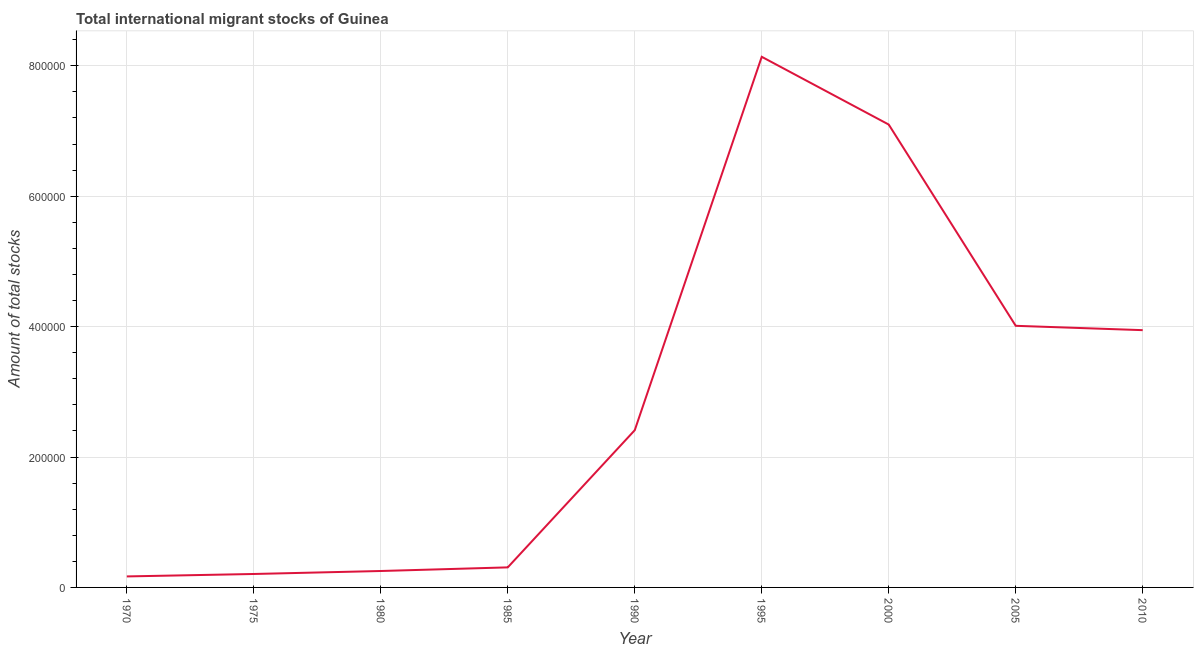What is the total number of international migrant stock in 1970?
Provide a succinct answer. 1.69e+04. Across all years, what is the maximum total number of international migrant stock?
Your response must be concise. 8.14e+05. Across all years, what is the minimum total number of international migrant stock?
Give a very brief answer. 1.69e+04. In which year was the total number of international migrant stock minimum?
Your response must be concise. 1970. What is the sum of the total number of international migrant stock?
Your answer should be very brief. 2.65e+06. What is the difference between the total number of international migrant stock in 1990 and 2005?
Your response must be concise. -1.60e+05. What is the average total number of international migrant stock per year?
Offer a very short reply. 2.95e+05. What is the median total number of international migrant stock?
Provide a short and direct response. 2.41e+05. In how many years, is the total number of international migrant stock greater than 240000 ?
Keep it short and to the point. 5. What is the ratio of the total number of international migrant stock in 1980 to that in 2000?
Your answer should be very brief. 0.04. Is the total number of international migrant stock in 1980 less than that in 1995?
Keep it short and to the point. Yes. What is the difference between the highest and the second highest total number of international migrant stock?
Your answer should be compact. 1.04e+05. What is the difference between the highest and the lowest total number of international migrant stock?
Give a very brief answer. 7.97e+05. How many lines are there?
Offer a very short reply. 1. Are the values on the major ticks of Y-axis written in scientific E-notation?
Your response must be concise. No. Does the graph contain any zero values?
Your response must be concise. No. What is the title of the graph?
Keep it short and to the point. Total international migrant stocks of Guinea. What is the label or title of the Y-axis?
Give a very brief answer. Amount of total stocks. What is the Amount of total stocks of 1970?
Your answer should be very brief. 1.69e+04. What is the Amount of total stocks of 1975?
Ensure brevity in your answer.  2.06e+04. What is the Amount of total stocks of 1980?
Keep it short and to the point. 2.52e+04. What is the Amount of total stocks in 1985?
Give a very brief answer. 3.08e+04. What is the Amount of total stocks in 1990?
Give a very brief answer. 2.41e+05. What is the Amount of total stocks in 1995?
Keep it short and to the point. 8.14e+05. What is the Amount of total stocks in 2000?
Offer a terse response. 7.10e+05. What is the Amount of total stocks of 2005?
Your answer should be compact. 4.01e+05. What is the Amount of total stocks of 2010?
Provide a short and direct response. 3.95e+05. What is the difference between the Amount of total stocks in 1970 and 1975?
Ensure brevity in your answer.  -3737. What is the difference between the Amount of total stocks in 1970 and 1980?
Provide a succinct answer. -8302. What is the difference between the Amount of total stocks in 1970 and 1985?
Provide a succinct answer. -1.39e+04. What is the difference between the Amount of total stocks in 1970 and 1990?
Your answer should be very brief. -2.24e+05. What is the difference between the Amount of total stocks in 1970 and 1995?
Make the answer very short. -7.97e+05. What is the difference between the Amount of total stocks in 1970 and 2000?
Make the answer very short. -6.93e+05. What is the difference between the Amount of total stocks in 1970 and 2005?
Provide a succinct answer. -3.84e+05. What is the difference between the Amount of total stocks in 1970 and 2010?
Your answer should be very brief. -3.78e+05. What is the difference between the Amount of total stocks in 1975 and 1980?
Offer a very short reply. -4565. What is the difference between the Amount of total stocks in 1975 and 1985?
Your answer should be very brief. -1.01e+04. What is the difference between the Amount of total stocks in 1975 and 1990?
Your response must be concise. -2.21e+05. What is the difference between the Amount of total stocks in 1975 and 1995?
Provide a short and direct response. -7.93e+05. What is the difference between the Amount of total stocks in 1975 and 2000?
Ensure brevity in your answer.  -6.89e+05. What is the difference between the Amount of total stocks in 1975 and 2005?
Provide a short and direct response. -3.81e+05. What is the difference between the Amount of total stocks in 1975 and 2010?
Offer a very short reply. -3.74e+05. What is the difference between the Amount of total stocks in 1980 and 1985?
Your answer should be very brief. -5575. What is the difference between the Amount of total stocks in 1980 and 1990?
Ensure brevity in your answer.  -2.16e+05. What is the difference between the Amount of total stocks in 1980 and 1995?
Your answer should be compact. -7.89e+05. What is the difference between the Amount of total stocks in 1980 and 2000?
Offer a very short reply. -6.85e+05. What is the difference between the Amount of total stocks in 1980 and 2005?
Offer a terse response. -3.76e+05. What is the difference between the Amount of total stocks in 1980 and 2010?
Provide a short and direct response. -3.69e+05. What is the difference between the Amount of total stocks in 1985 and 1990?
Offer a very short reply. -2.10e+05. What is the difference between the Amount of total stocks in 1985 and 1995?
Keep it short and to the point. -7.83e+05. What is the difference between the Amount of total stocks in 1985 and 2000?
Give a very brief answer. -6.79e+05. What is the difference between the Amount of total stocks in 1985 and 2005?
Offer a terse response. -3.70e+05. What is the difference between the Amount of total stocks in 1985 and 2010?
Keep it short and to the point. -3.64e+05. What is the difference between the Amount of total stocks in 1990 and 1995?
Offer a terse response. -5.73e+05. What is the difference between the Amount of total stocks in 1990 and 2000?
Offer a terse response. -4.69e+05. What is the difference between the Amount of total stocks in 1990 and 2005?
Your response must be concise. -1.60e+05. What is the difference between the Amount of total stocks in 1990 and 2010?
Give a very brief answer. -1.53e+05. What is the difference between the Amount of total stocks in 1995 and 2000?
Offer a terse response. 1.04e+05. What is the difference between the Amount of total stocks in 1995 and 2005?
Offer a very short reply. 4.13e+05. What is the difference between the Amount of total stocks in 1995 and 2010?
Ensure brevity in your answer.  4.19e+05. What is the difference between the Amount of total stocks in 2000 and 2005?
Your answer should be very brief. 3.09e+05. What is the difference between the Amount of total stocks in 2000 and 2010?
Offer a terse response. 3.15e+05. What is the difference between the Amount of total stocks in 2005 and 2010?
Your answer should be very brief. 6660. What is the ratio of the Amount of total stocks in 1970 to that in 1975?
Ensure brevity in your answer.  0.82. What is the ratio of the Amount of total stocks in 1970 to that in 1980?
Make the answer very short. 0.67. What is the ratio of the Amount of total stocks in 1970 to that in 1985?
Ensure brevity in your answer.  0.55. What is the ratio of the Amount of total stocks in 1970 to that in 1990?
Offer a very short reply. 0.07. What is the ratio of the Amount of total stocks in 1970 to that in 1995?
Your answer should be very brief. 0.02. What is the ratio of the Amount of total stocks in 1970 to that in 2000?
Keep it short and to the point. 0.02. What is the ratio of the Amount of total stocks in 1970 to that in 2005?
Keep it short and to the point. 0.04. What is the ratio of the Amount of total stocks in 1970 to that in 2010?
Your answer should be very brief. 0.04. What is the ratio of the Amount of total stocks in 1975 to that in 1980?
Give a very brief answer. 0.82. What is the ratio of the Amount of total stocks in 1975 to that in 1985?
Ensure brevity in your answer.  0.67. What is the ratio of the Amount of total stocks in 1975 to that in 1990?
Keep it short and to the point. 0.09. What is the ratio of the Amount of total stocks in 1975 to that in 1995?
Provide a short and direct response. 0.03. What is the ratio of the Amount of total stocks in 1975 to that in 2000?
Offer a very short reply. 0.03. What is the ratio of the Amount of total stocks in 1975 to that in 2005?
Provide a succinct answer. 0.05. What is the ratio of the Amount of total stocks in 1975 to that in 2010?
Your answer should be very brief. 0.05. What is the ratio of the Amount of total stocks in 1980 to that in 1985?
Keep it short and to the point. 0.82. What is the ratio of the Amount of total stocks in 1980 to that in 1990?
Keep it short and to the point. 0.1. What is the ratio of the Amount of total stocks in 1980 to that in 1995?
Provide a succinct answer. 0.03. What is the ratio of the Amount of total stocks in 1980 to that in 2000?
Provide a short and direct response. 0.04. What is the ratio of the Amount of total stocks in 1980 to that in 2005?
Ensure brevity in your answer.  0.06. What is the ratio of the Amount of total stocks in 1980 to that in 2010?
Make the answer very short. 0.06. What is the ratio of the Amount of total stocks in 1985 to that in 1990?
Your response must be concise. 0.13. What is the ratio of the Amount of total stocks in 1985 to that in 1995?
Your answer should be very brief. 0.04. What is the ratio of the Amount of total stocks in 1985 to that in 2000?
Your answer should be very brief. 0.04. What is the ratio of the Amount of total stocks in 1985 to that in 2005?
Your response must be concise. 0.08. What is the ratio of the Amount of total stocks in 1985 to that in 2010?
Provide a short and direct response. 0.08. What is the ratio of the Amount of total stocks in 1990 to that in 1995?
Your answer should be very brief. 0.3. What is the ratio of the Amount of total stocks in 1990 to that in 2000?
Your answer should be very brief. 0.34. What is the ratio of the Amount of total stocks in 1990 to that in 2005?
Provide a succinct answer. 0.6. What is the ratio of the Amount of total stocks in 1990 to that in 2010?
Ensure brevity in your answer.  0.61. What is the ratio of the Amount of total stocks in 1995 to that in 2000?
Make the answer very short. 1.15. What is the ratio of the Amount of total stocks in 1995 to that in 2005?
Give a very brief answer. 2.03. What is the ratio of the Amount of total stocks in 1995 to that in 2010?
Your answer should be very brief. 2.06. What is the ratio of the Amount of total stocks in 2000 to that in 2005?
Keep it short and to the point. 1.77. What is the ratio of the Amount of total stocks in 2000 to that in 2010?
Provide a short and direct response. 1.8. 